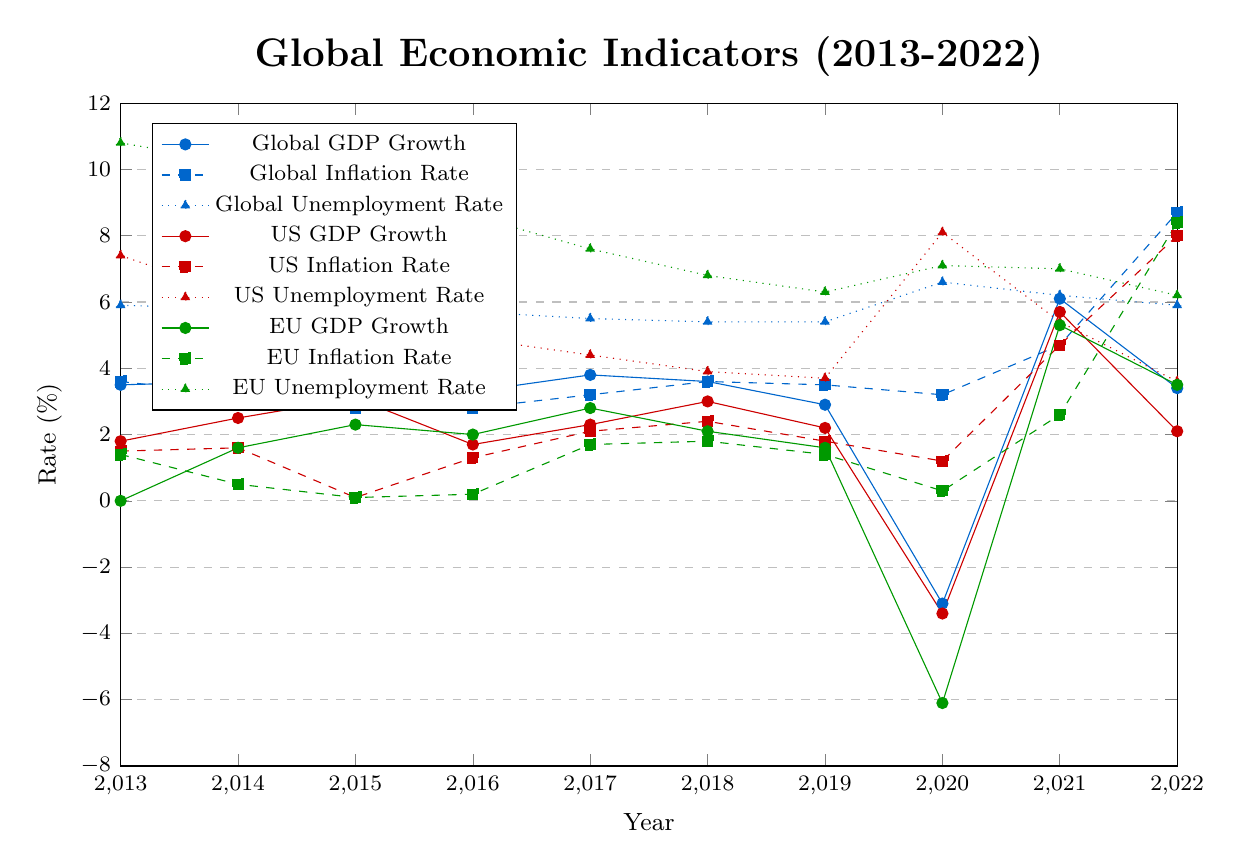What's the overall trend of the Global GDP Growth rate from 2013 to 2022? The Global GDP Growth rate fluctuates but generally decreases from 2013 to 2019, drops sharply in 2020, and then rebounds strongly in 2021 before stabilizing in 2022.
Answer: Generally decreasing with fluctuations Which year experienced the highest US GDP Growth, and what was the rate? By examining the US GDP Growth line, the highest GDP growth occurred in 2021, with a rate of 5.7%.
Answer: 2021, 5.7% How did the EU GDP Growth rate change from 2019 to 2020, and what does this indicate about the EU economy at that time? The EU GDP Growth rate dropped from 1.6% in 2019 to -6.1% in 2020, indicating a severe economic contraction likely due to the COVID-19 pandemic.
Answer: Dropped by 7.7%, severe contraction Compare the Global Inflation Rate and US Inflation Rate trends from 2013 to 2022. Both the Global Inflation Rate and US Inflation Rate had a gradual increase until 2021, with a rapid spike in 2022. The Global rate peaked at 8.7% and the US rate at 8.0%.
Answer: Similar trends with a spike in 2022 What was the unemployment rate in the US and the EU during the year 2020, and which one was higher? In 2020, the US unemployment rate was 8.1%, while the EU unemployment rate was 7.1%. The US rate was higher that year.
Answer: 8.1% (US), 7.1% (EU); US was higher If you average the Global Inflation Rate over the decade, what is the result? Adding the Global Inflation Rates from 2013 to 2022 gives a sum of 37.3. There are 10 years, so the average is 37.3/10 = 3.73.
Answer: 3.73% Which region had a higher GDP growth rate in 2018, US or EU? In 2018, the US GDP growth rate was 3.0%, while the EU GDP growth rate was 2.1%. The US had a higher GDP growth rate.
Answer: US, 3.0% During which years did the Global Unemployment Rate remain constant, and what was the rate? The Global Unemployment Rate remained constant at 5.7% during 2015 and 2016.
Answer: 2015 and 2016, 5.7% What is the difference between the EU and Global Unemployment Rates in 2019? The EU Unemployment Rate in 2019 was 6.3%, and the Global Unemployment Rate was 5.4%. The difference is 6.3% - 5.4% = 0.9%.
Answer: 0.9% 